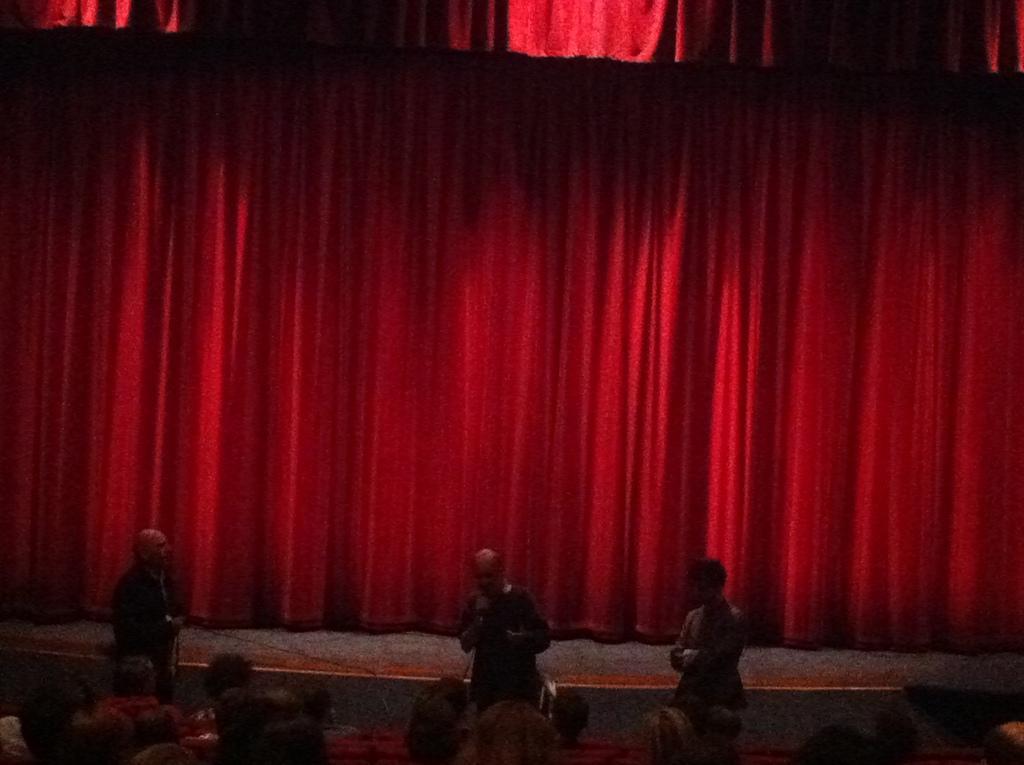Please provide a concise description of this image. In this picture we can see the heads of a few people at the bottom of the picture. We can see a person holding a microphone and standing. There are two people standing. We can see a curtain in the background. 